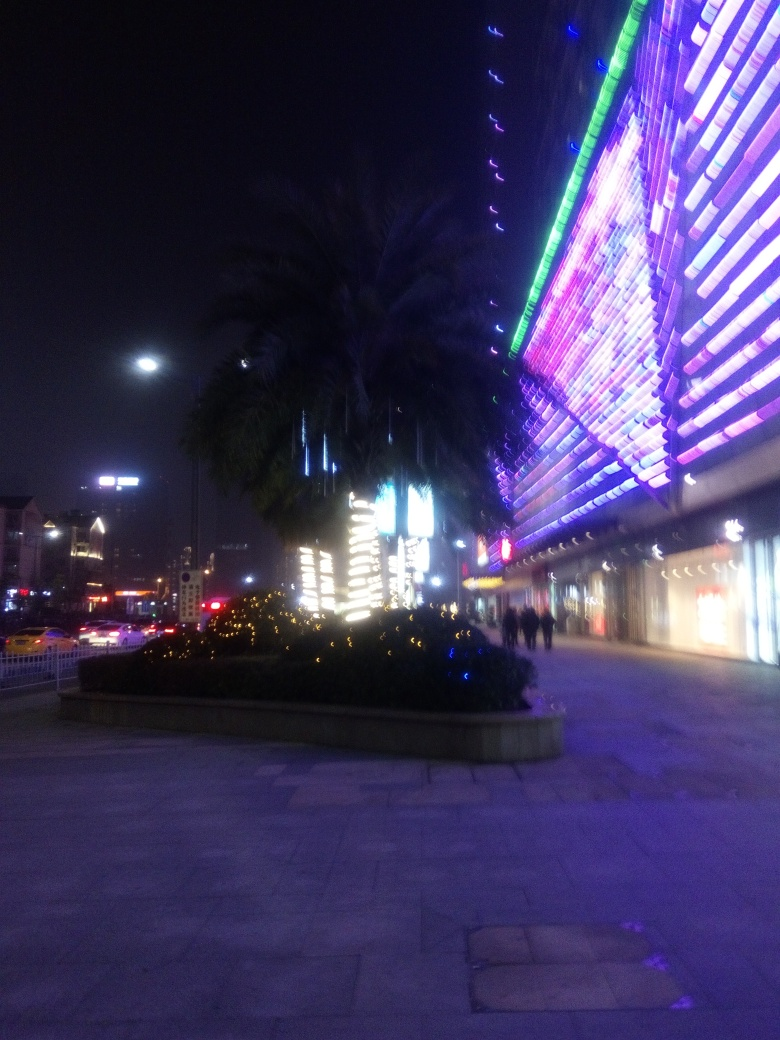Why is most of the content invisible?
A. high contrast
B. proper exposure
C. overexposure
D. underexposure The most likely cause for most of the content being invisible in the photo is D. underexposure. The underexposure happens when the camera's sensor does not capture enough light, resulting in a darker image where details are lost, especially in areas with low ambient light. 